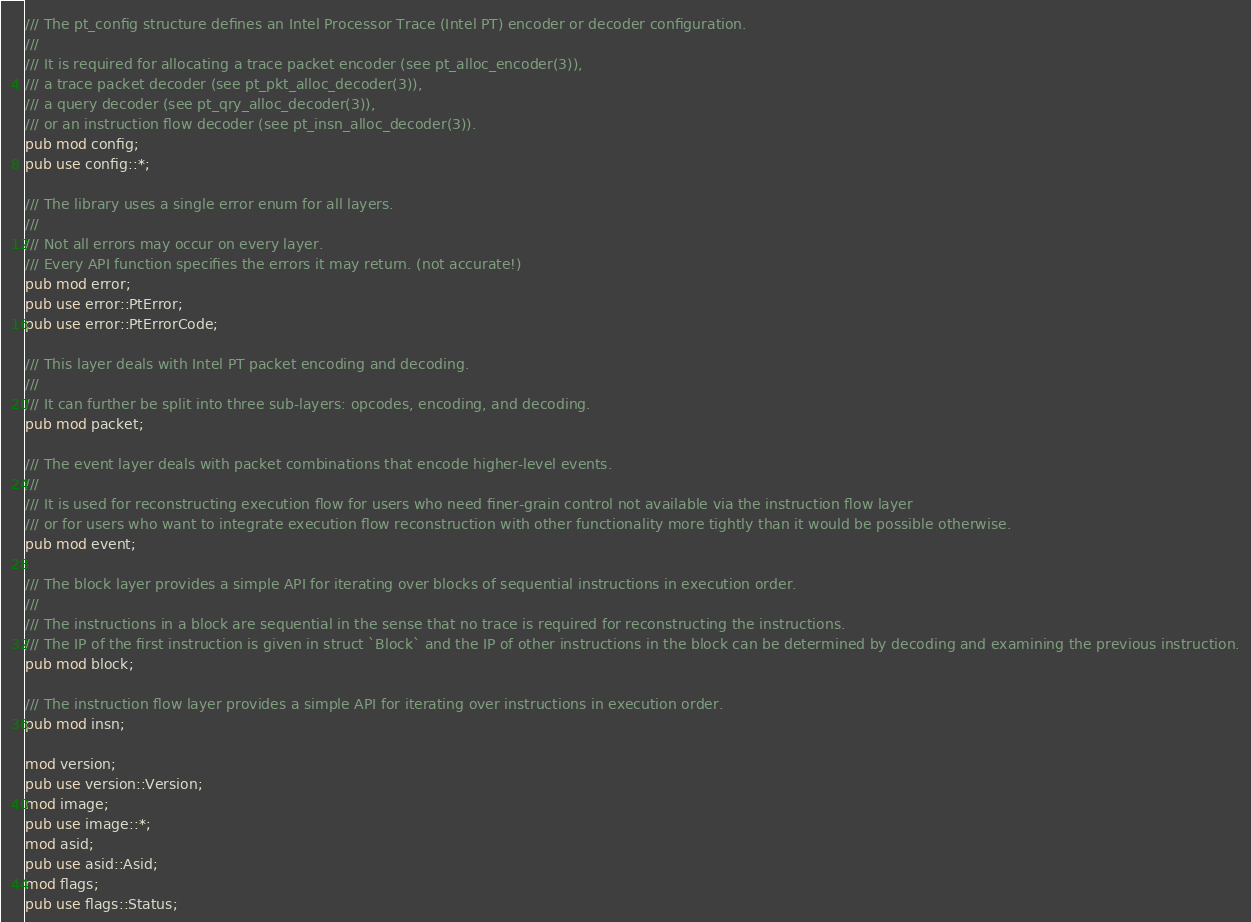Convert code to text. <code><loc_0><loc_0><loc_500><loc_500><_Rust_>/// The pt_config structure defines an Intel Processor Trace (Intel PT) encoder or decoder configuration.
///
/// It is required for allocating a trace packet encoder (see pt_alloc_encoder(3)),
/// a trace packet decoder (see pt_pkt_alloc_decoder(3)),
/// a query decoder (see pt_qry_alloc_decoder(3)),
/// or an instruction flow decoder (see pt_insn_alloc_decoder(3)).
pub mod config;
pub use config::*;

/// The library uses a single error enum for all layers.
///
/// Not all errors may occur on every layer.
/// Every API function specifies the errors it may return. (not accurate!)
pub mod error;
pub use error::PtError;
pub use error::PtErrorCode;

/// This layer deals with Intel PT packet encoding and decoding.
///
/// It can further be split into three sub-layers: opcodes, encoding, and decoding.
pub mod packet;

/// The event layer deals with packet combinations that encode higher-level events.
///
/// It is used for reconstructing execution flow for users who need finer-grain control not available via the instruction flow layer
/// or for users who want to integrate execution flow reconstruction with other functionality more tightly than it would be possible otherwise.
pub mod event;

/// The block layer provides a simple API for iterating over blocks of sequential instructions in execution order.
///
/// The instructions in a block are sequential in the sense that no trace is required for reconstructing the instructions.
/// The IP of the first instruction is given in struct `Block` and the IP of other instructions in the block can be determined by decoding and examining the previous instruction.
pub mod block;

/// The instruction flow layer provides a simple API for iterating over instructions in execution order.
pub mod insn;

mod version;
pub use version::Version;
mod image;
pub use image::*;
mod asid;
pub use asid::Asid;
mod flags;
pub use flags::Status;</code> 